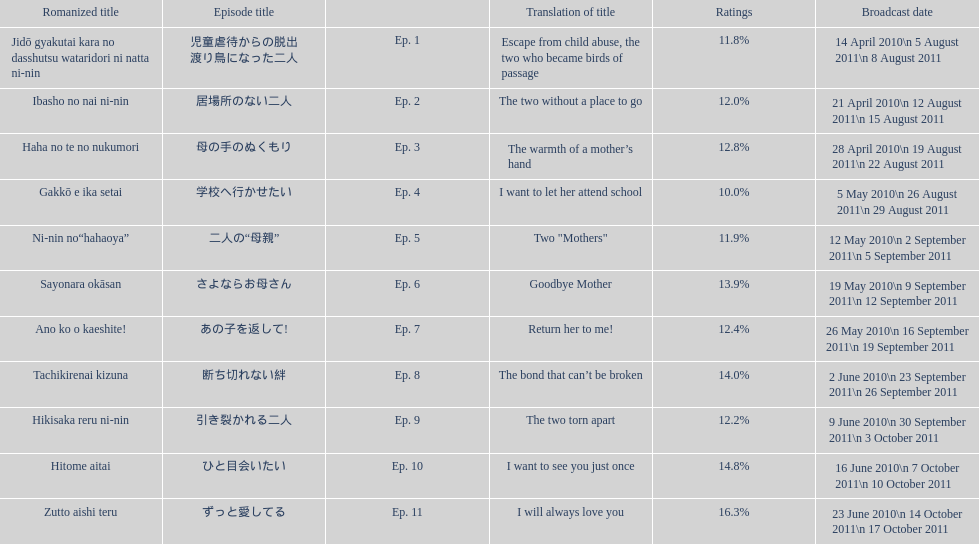How many episode are not over 14%? 8. 